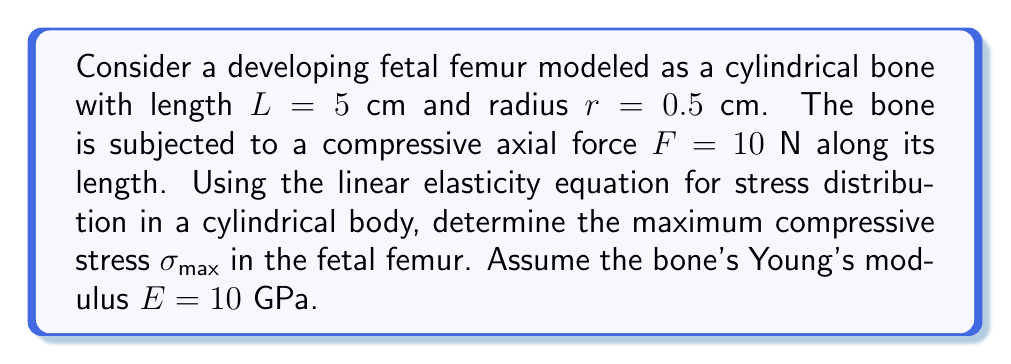Teach me how to tackle this problem. To solve this problem, we'll use the linear elasticity equation for stress distribution in a cylindrical body under axial compression:

$$\sigma = \frac{F}{A}$$

Where:
$\sigma$ is the stress (in Pa)
$F$ is the applied force (in N)
$A$ is the cross-sectional area of the cylinder (in m²)

Steps to solve:

1. Calculate the cross-sectional area of the femur:
   $$A = \pi r^2 = \pi (0.5 \times 10^{-2})^2 = 7.854 \times 10^{-5} \text{ m}^2$$

2. Apply the stress equation:
   $$\sigma_{max} = \frac{F}{A} = \frac{10}{7.854 \times 10^{-5}} = 1.273 \times 10^5 \text{ Pa}$$

3. Convert the result to MPa for easier interpretation:
   $$\sigma_{max} = 1.273 \times 10^5 \text{ Pa} = 0.1273 \text{ MPa}$$

It's important to note that this simplified model assumes uniform stress distribution and doesn't account for the complex geometry and material properties of developing fetal bones. In reality, stress distribution in fetal bones would be more complex due to their developing nature and the presence of softer cartilaginous regions.
Answer: The maximum compressive stress in the fetal femur is $\sigma_{max} = 0.1273 \text{ MPa}$. 